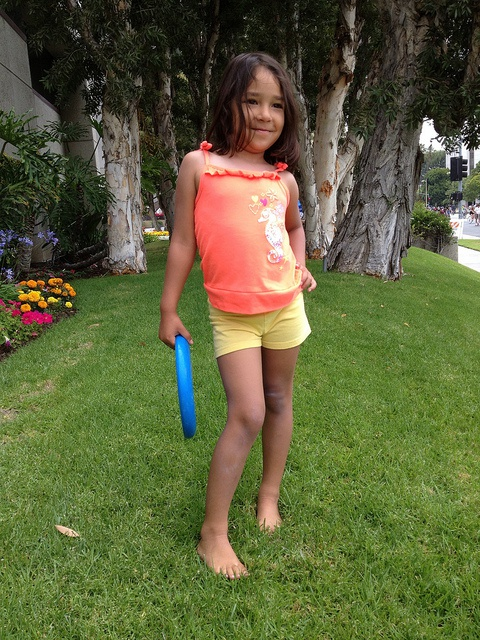Describe the objects in this image and their specific colors. I can see people in black, brown, and salmon tones, frisbee in black, lightblue, blue, and navy tones, traffic light in black, gray, and darkgray tones, and traffic light in black, brown, and gray tones in this image. 